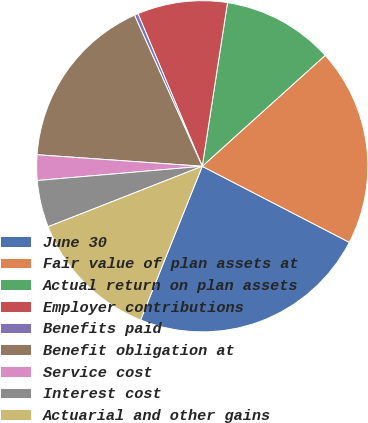Convert chart. <chart><loc_0><loc_0><loc_500><loc_500><pie_chart><fcel>June 30<fcel>Fair value of plan assets at<fcel>Actual return on plan assets<fcel>Employer contributions<fcel>Benefits paid<fcel>Benefit obligation at<fcel>Service cost<fcel>Interest cost<fcel>Actuarial and other gains<nl><fcel>23.48%<fcel>19.28%<fcel>10.88%<fcel>8.78%<fcel>0.37%<fcel>17.18%<fcel>2.48%<fcel>4.58%<fcel>12.98%<nl></chart> 